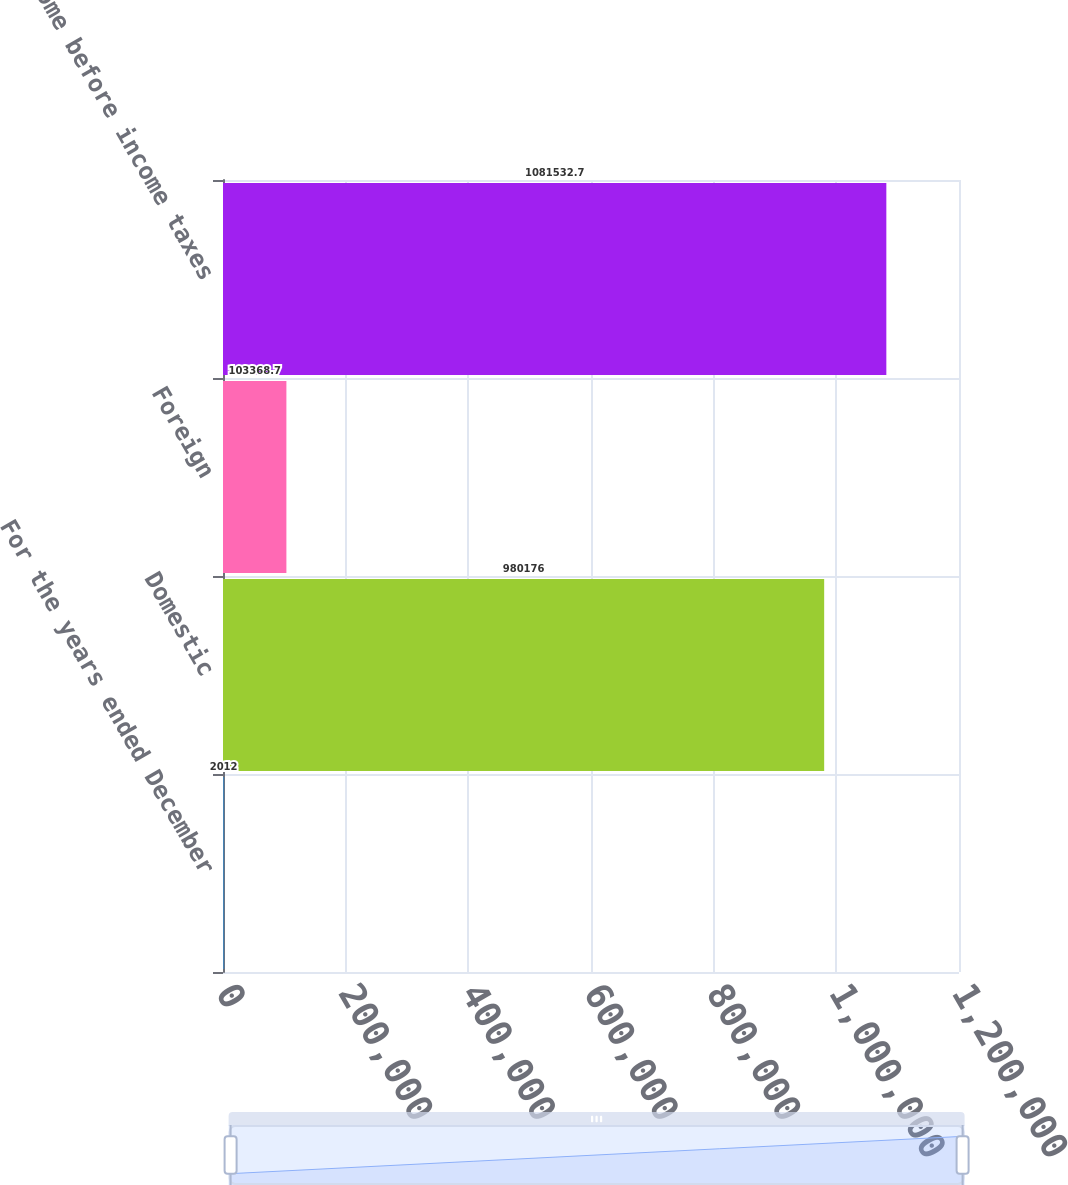Convert chart. <chart><loc_0><loc_0><loc_500><loc_500><bar_chart><fcel>For the years ended December<fcel>Domestic<fcel>Foreign<fcel>Income before income taxes<nl><fcel>2012<fcel>980176<fcel>103369<fcel>1.08153e+06<nl></chart> 